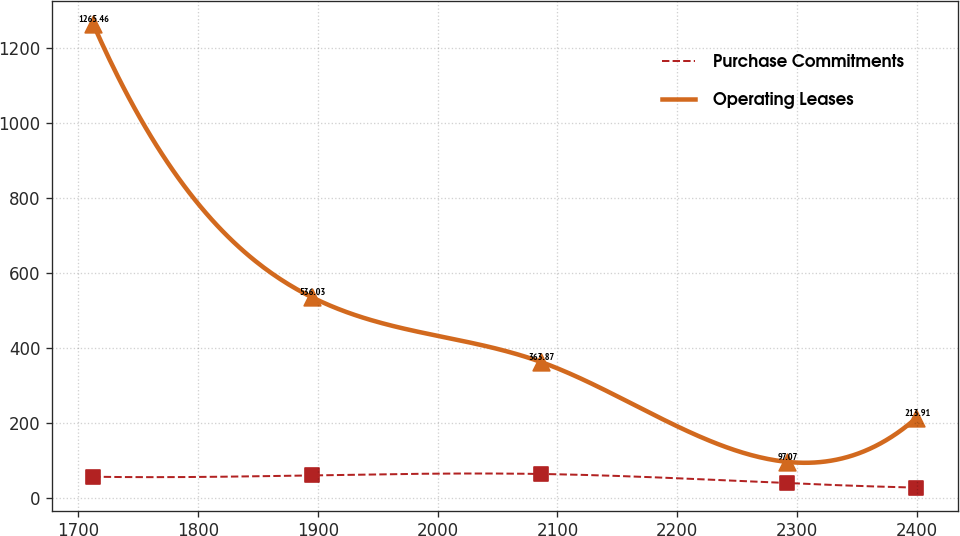Convert chart to OTSL. <chart><loc_0><loc_0><loc_500><loc_500><line_chart><ecel><fcel>Purchase Commitments<fcel>Operating Leases<nl><fcel>1712.67<fcel>57.37<fcel>1265.46<nl><fcel>1895.27<fcel>61<fcel>536.03<nl><fcel>2085.9<fcel>64.73<fcel>363.87<nl><fcel>2291.42<fcel>40.4<fcel>97.07<nl><fcel>2399.36<fcel>28.41<fcel>213.91<nl></chart> 